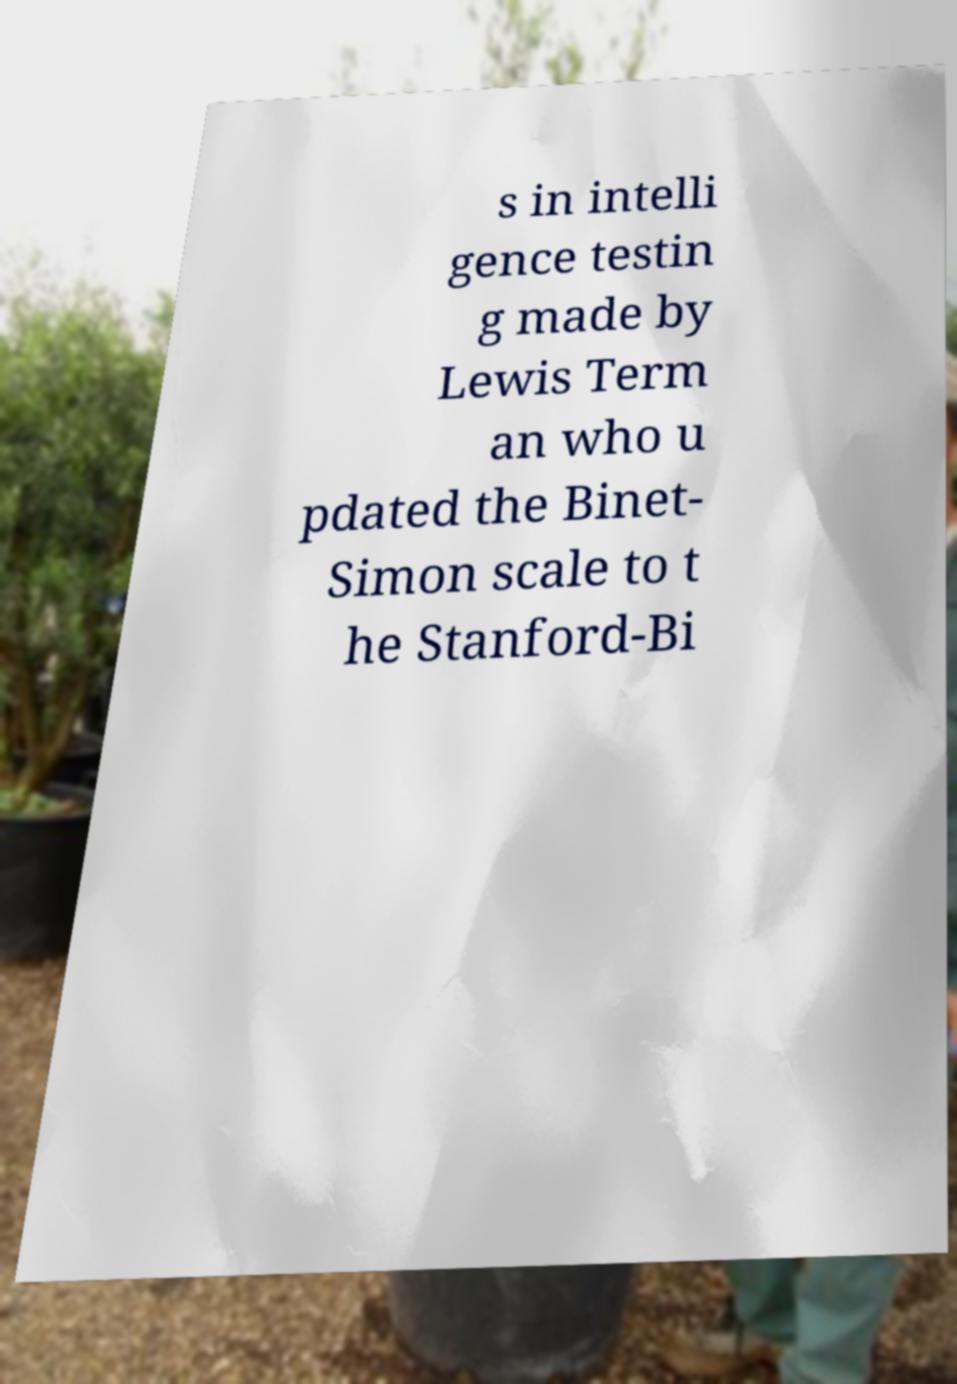Can you read and provide the text displayed in the image?This photo seems to have some interesting text. Can you extract and type it out for me? s in intelli gence testin g made by Lewis Term an who u pdated the Binet- Simon scale to t he Stanford-Bi 